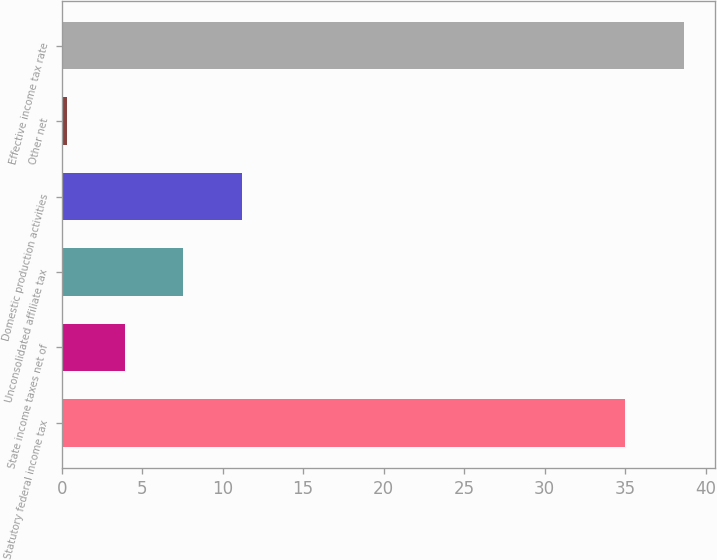<chart> <loc_0><loc_0><loc_500><loc_500><bar_chart><fcel>Statutory federal income tax<fcel>State income taxes net of<fcel>Unconsolidated affiliate tax<fcel>Domestic production activities<fcel>Other net<fcel>Effective income tax rate<nl><fcel>35<fcel>3.93<fcel>7.56<fcel>11.19<fcel>0.3<fcel>38.63<nl></chart> 